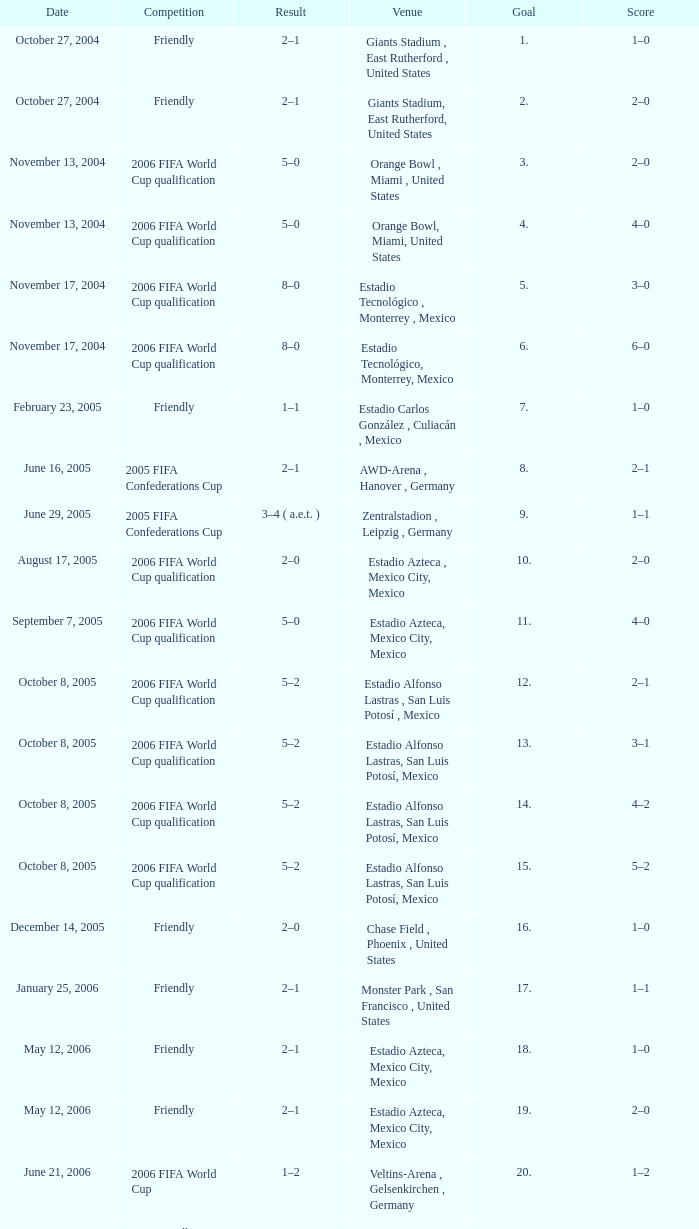Which Competition has a Venue of estadio alfonso lastras, san luis potosí, mexico, and a Goal larger than 15? Friendly. 